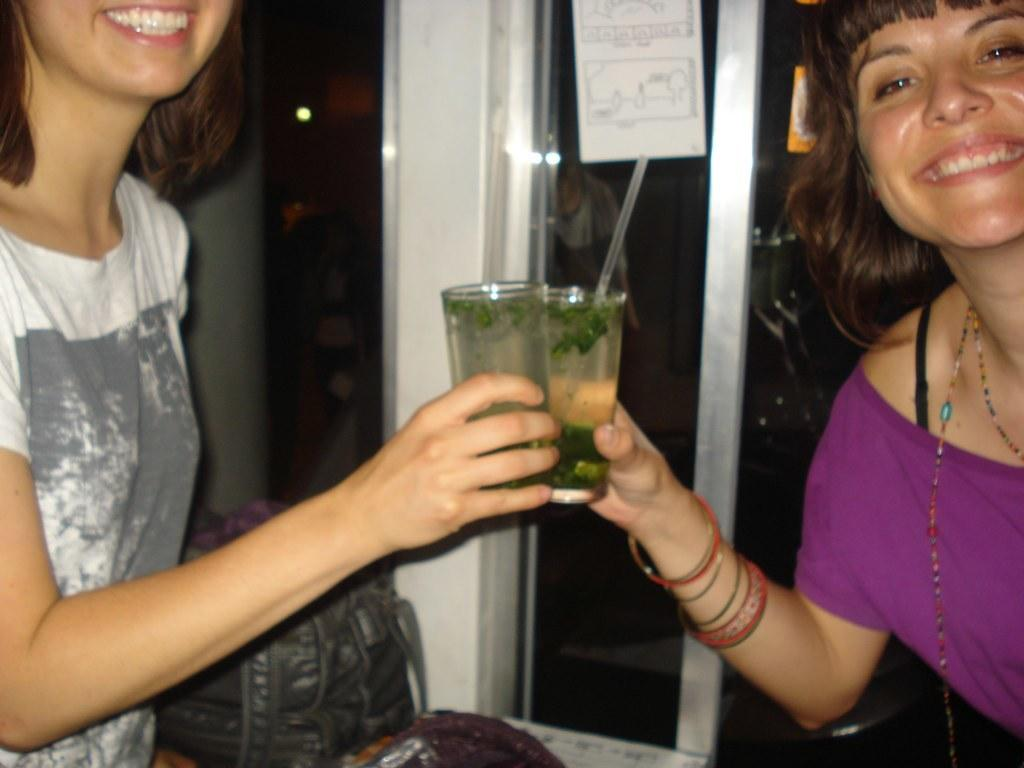How many women are present in the image? There are two women in the image. What are the women holding in their hands? The women are holding glasses. What can be seen in the background of the image? There is a bag, a glass, and a poster in the background of the image. What type of juice is being dropped on the floor in the image? There is no juice or any indication of a drop on the floor in the image. 